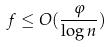Convert formula to latex. <formula><loc_0><loc_0><loc_500><loc_500>f \leq O ( \frac { \varphi } { \log n } )</formula> 